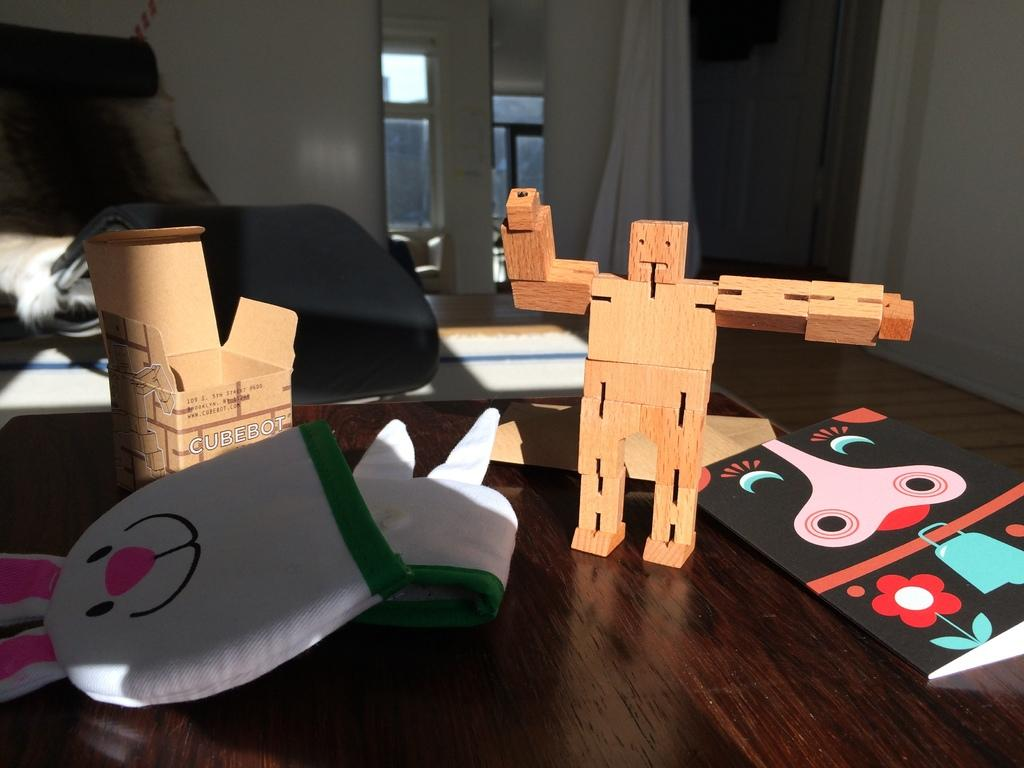<image>
Present a compact description of the photo's key features. A human figure mad out of interlocking wooden blocks called a "Cubebot". 